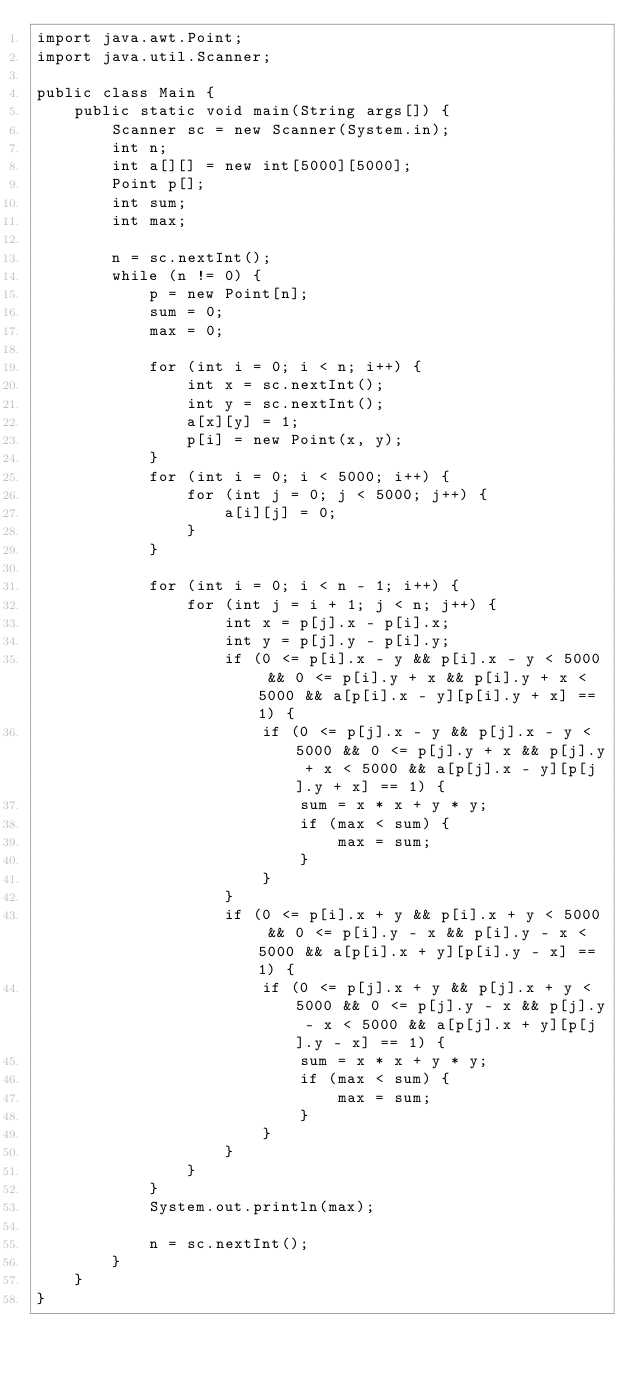Convert code to text. <code><loc_0><loc_0><loc_500><loc_500><_Java_>import java.awt.Point;
import java.util.Scanner;

public class Main {
	public static void main(String args[]) {
		Scanner sc = new Scanner(System.in);
		int n;
		int a[][] = new int[5000][5000];
		Point p[];
		int sum;
		int max;

		n = sc.nextInt();
		while (n != 0) {
			p = new Point[n];
			sum = 0;
			max = 0;

			for (int i = 0; i < n; i++) {
				int x = sc.nextInt();
				int y = sc.nextInt();
				a[x][y] = 1;
				p[i] = new Point(x, y);
			}
			for (int i = 0; i < 5000; i++) {
				for (int j = 0; j < 5000; j++) {
					a[i][j] = 0;
				}
			}

			for (int i = 0; i < n - 1; i++) {
				for (int j = i + 1; j < n; j++) {
					int x = p[j].x - p[i].x;
					int y = p[j].y - p[i].y;
					if (0 <= p[i].x - y && p[i].x - y < 5000 && 0 <= p[i].y + x && p[i].y + x < 5000 && a[p[i].x - y][p[i].y + x] == 1) {
						if (0 <= p[j].x - y && p[j].x - y < 5000 && 0 <= p[j].y + x && p[j].y + x < 5000 && a[p[j].x - y][p[j].y + x] == 1) {
							sum = x * x + y * y;
							if (max < sum) {
								max = sum;
							}
						}
					}
					if (0 <= p[i].x + y && p[i].x + y < 5000 && 0 <= p[i].y - x && p[i].y - x < 5000 && a[p[i].x + y][p[i].y - x] == 1) {
						if (0 <= p[j].x + y && p[j].x + y < 5000 && 0 <= p[j].y - x && p[j].y - x < 5000 && a[p[j].x + y][p[j].y - x] == 1) {
							sum = x * x + y * y;
							if (max < sum) {
								max = sum;
							}
						}
					}
				}
			}
			System.out.println(max);

			n = sc.nextInt();
		}
	}
}</code> 